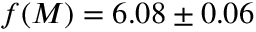<formula> <loc_0><loc_0><loc_500><loc_500>f ( M ) = 6 . 0 8 \pm 0 . 0 6</formula> 